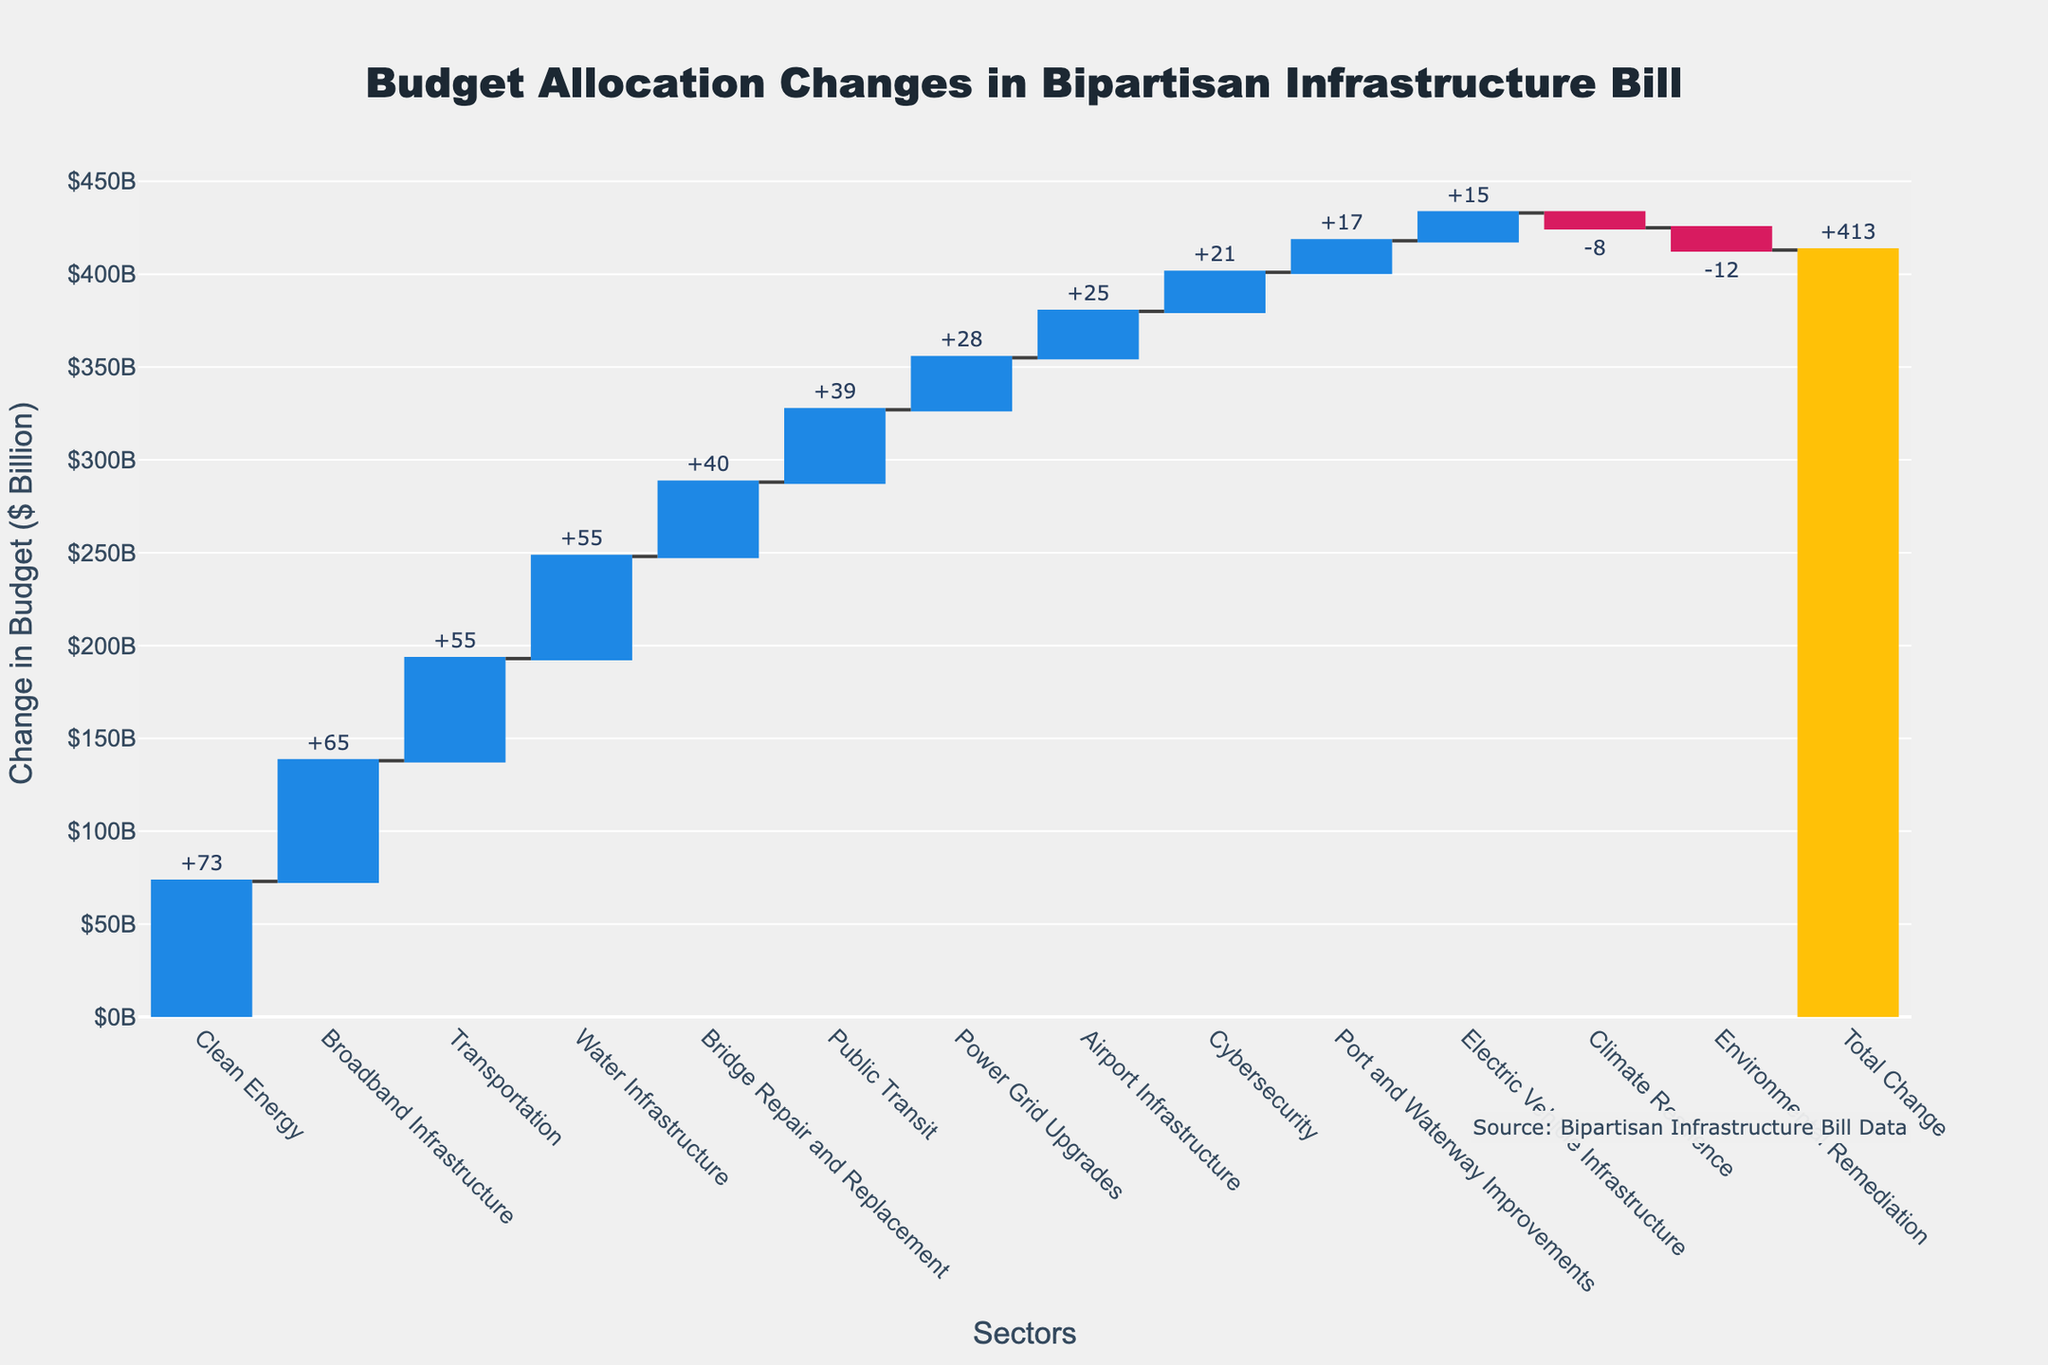What is the total change in budget allocation shown in the chart? The total change in budget allocation can be found at the end of the chart, displayed as the last bar in a different color. The total change is given as +413.
Answer: +413 Which sector shows the highest increase in budget allocation? To identify the sector with the highest increase, look for the largest positive bar. Clean Energy shows the highest increase with +73.
Answer: Clean Energy How many sectors have a decrease in budget allocation? Count the negative bars in the chart. Environmental Remediation and Climate Resilience are the only sectors with decreases, making it a total of 2 sectors.
Answer: 2 What is the change in budget allocation for Electric Vehicle Infrastructure? Find the bar labeled "Electric Vehicle Infrastructure" and check its value. The change is +15.
Answer: +15 Which sectors have a budget allocation change greater than $50 billion? Visually identify and list all bars with values greater than 50. Transportation, Clean Energy, Broadband Infrastructure, and Water Infrastructure each have changes greater than $50 billion.
Answer: Transportation, Clean Energy, Broadband Infrastructure, Water Infrastructure Compare the budget changes for Public Transit and Transportation. Which one has a higher increase? Look for both "Public Transit" and "Transportation" bars and compare their values. Transportation has an increase of +55, which is higher than Public Transit's +39.
Answer: Transportation Calculate the combined budget change for Transportation and Bridge Repair and Replacement. Add the changes for Transportation (+55) and Bridge Repair and Replacement (+40). The combined change is 55 + 40 = 95.
Answer: 95 What is the net change in budget allocation for sectors related to environmental improvements? Sum the changes for Clean Energy (+73), Environmental Remediation (-12), Climate Resilience (-8), and Cybersecurity (+21). The net change is 73 - 12 - 8 + 21 = 74.
Answer: 74 Which has a greater budget increase: Airport Infrastructure or Port and Waterway Improvements? Compare the bars for "Airport Infrastructure" (+25) and "Port and Waterway Improvements" (+17). Airport Infrastructure has the greater increase.
Answer: Airport Infrastructure 